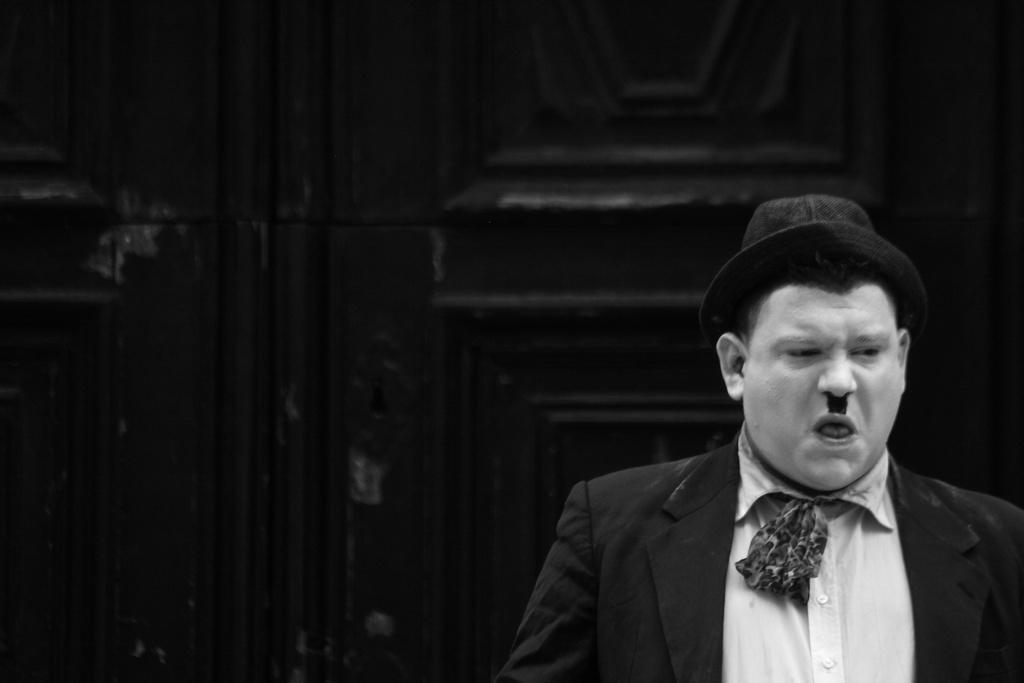Could you give a brief overview of what you see in this image? In this black and white image, we can see a person in front of the wall wearing clothes and hat. 